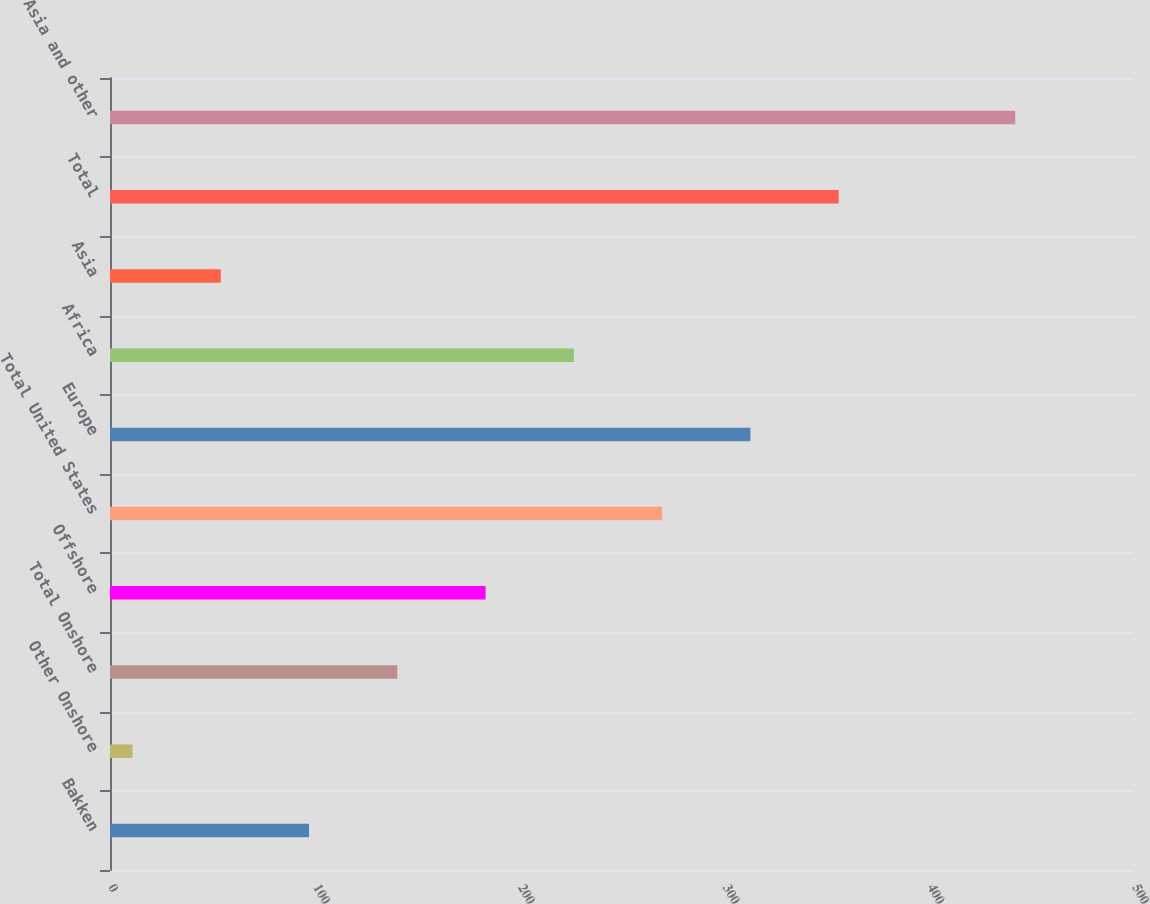Convert chart. <chart><loc_0><loc_0><loc_500><loc_500><bar_chart><fcel>Bakken<fcel>Other Onshore<fcel>Total Onshore<fcel>Offshore<fcel>Total United States<fcel>Europe<fcel>Africa<fcel>Asia<fcel>Total<fcel>Asia and other<nl><fcel>97.2<fcel>11<fcel>140.3<fcel>183.4<fcel>269.6<fcel>312.7<fcel>226.5<fcel>54.1<fcel>355.8<fcel>442<nl></chart> 